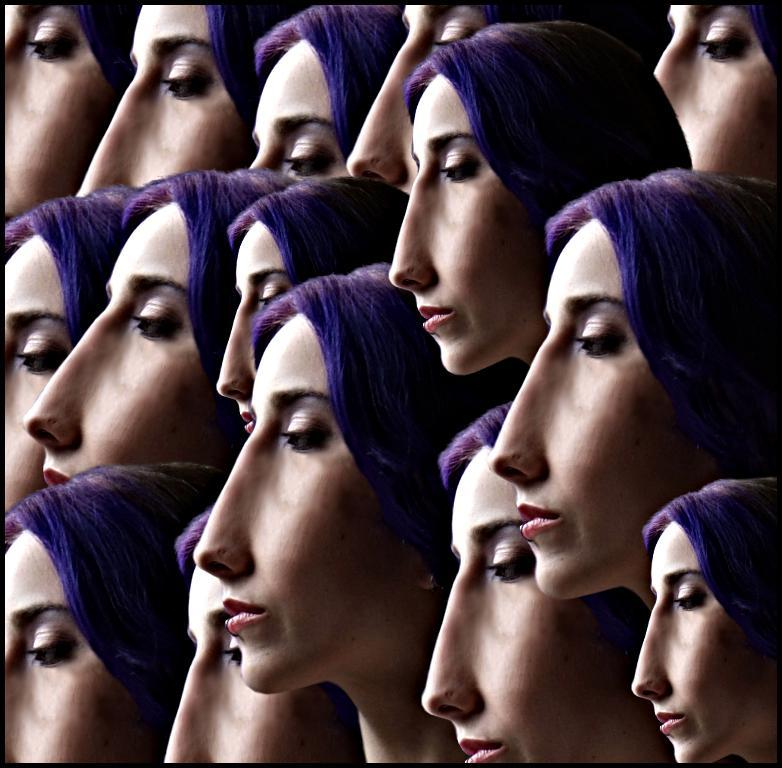What can be observed about the image's appearance? The image appears to be edited. What is the main subject of the image? There is a person's face in the image. What feature can be seen on the person's head? The person has hair. What type of crime is being committed in the image? There is no indication of a crime being committed in the image; it features a person's face with hair. What camp activities can be seen in the image? There is no camp or camp activities present in the image; it features a person's face with hair. 